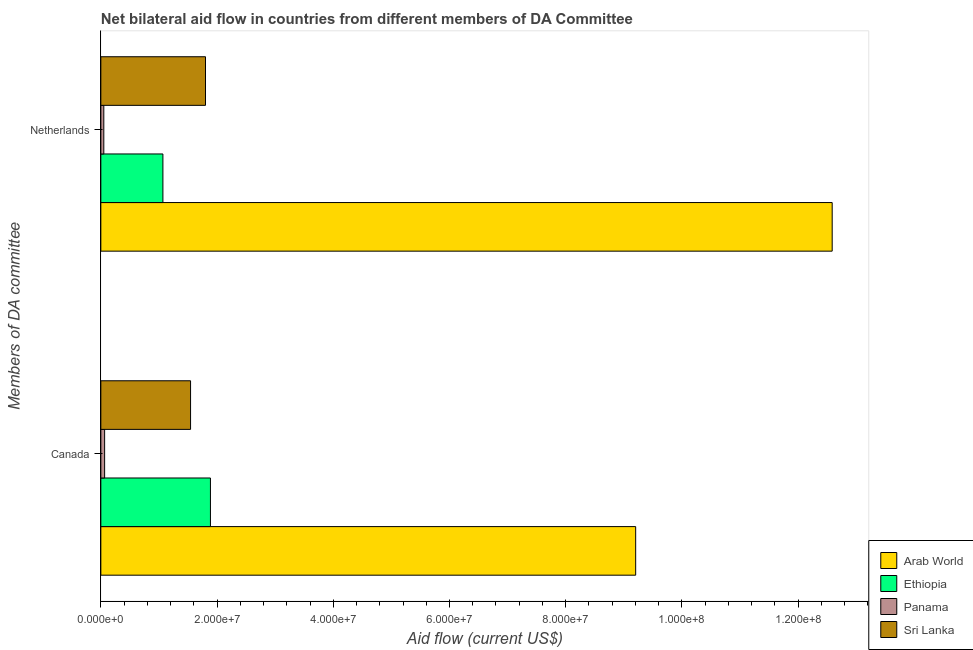How many different coloured bars are there?
Offer a terse response. 4. How many groups of bars are there?
Ensure brevity in your answer.  2. Are the number of bars on each tick of the Y-axis equal?
Your response must be concise. Yes. How many bars are there on the 2nd tick from the top?
Offer a very short reply. 4. How many bars are there on the 1st tick from the bottom?
Offer a terse response. 4. What is the amount of aid given by canada in Arab World?
Your answer should be compact. 9.20e+07. Across all countries, what is the maximum amount of aid given by canada?
Your answer should be very brief. 9.20e+07. Across all countries, what is the minimum amount of aid given by canada?
Offer a terse response. 6.50e+05. In which country was the amount of aid given by canada maximum?
Keep it short and to the point. Arab World. In which country was the amount of aid given by netherlands minimum?
Ensure brevity in your answer.  Panama. What is the total amount of aid given by canada in the graph?
Provide a succinct answer. 1.27e+08. What is the difference between the amount of aid given by canada in Panama and that in Ethiopia?
Make the answer very short. -1.82e+07. What is the difference between the amount of aid given by canada in Ethiopia and the amount of aid given by netherlands in Panama?
Your answer should be compact. 1.84e+07. What is the average amount of aid given by canada per country?
Make the answer very short. 3.17e+07. What is the difference between the amount of aid given by netherlands and amount of aid given by canada in Panama?
Keep it short and to the point. -1.40e+05. What is the ratio of the amount of aid given by netherlands in Panama to that in Arab World?
Your answer should be very brief. 0. Is the amount of aid given by canada in Sri Lanka less than that in Panama?
Offer a terse response. No. What does the 4th bar from the top in Netherlands represents?
Provide a short and direct response. Arab World. What does the 1st bar from the bottom in Canada represents?
Keep it short and to the point. Arab World. Are all the bars in the graph horizontal?
Give a very brief answer. Yes. What is the difference between two consecutive major ticks on the X-axis?
Your response must be concise. 2.00e+07. Are the values on the major ticks of X-axis written in scientific E-notation?
Make the answer very short. Yes. How many legend labels are there?
Ensure brevity in your answer.  4. What is the title of the graph?
Keep it short and to the point. Net bilateral aid flow in countries from different members of DA Committee. Does "Namibia" appear as one of the legend labels in the graph?
Provide a succinct answer. No. What is the label or title of the Y-axis?
Offer a terse response. Members of DA committee. What is the Aid flow (current US$) of Arab World in Canada?
Keep it short and to the point. 9.20e+07. What is the Aid flow (current US$) of Ethiopia in Canada?
Offer a terse response. 1.89e+07. What is the Aid flow (current US$) of Panama in Canada?
Provide a succinct answer. 6.50e+05. What is the Aid flow (current US$) of Sri Lanka in Canada?
Ensure brevity in your answer.  1.54e+07. What is the Aid flow (current US$) of Arab World in Netherlands?
Make the answer very short. 1.26e+08. What is the Aid flow (current US$) in Ethiopia in Netherlands?
Your answer should be compact. 1.07e+07. What is the Aid flow (current US$) of Panama in Netherlands?
Your response must be concise. 5.10e+05. What is the Aid flow (current US$) of Sri Lanka in Netherlands?
Give a very brief answer. 1.80e+07. Across all Members of DA committee, what is the maximum Aid flow (current US$) in Arab World?
Offer a terse response. 1.26e+08. Across all Members of DA committee, what is the maximum Aid flow (current US$) in Ethiopia?
Keep it short and to the point. 1.89e+07. Across all Members of DA committee, what is the maximum Aid flow (current US$) in Panama?
Your response must be concise. 6.50e+05. Across all Members of DA committee, what is the maximum Aid flow (current US$) of Sri Lanka?
Your response must be concise. 1.80e+07. Across all Members of DA committee, what is the minimum Aid flow (current US$) in Arab World?
Your answer should be compact. 9.20e+07. Across all Members of DA committee, what is the minimum Aid flow (current US$) of Ethiopia?
Give a very brief answer. 1.07e+07. Across all Members of DA committee, what is the minimum Aid flow (current US$) in Panama?
Your answer should be very brief. 5.10e+05. Across all Members of DA committee, what is the minimum Aid flow (current US$) in Sri Lanka?
Your answer should be very brief. 1.54e+07. What is the total Aid flow (current US$) in Arab World in the graph?
Your answer should be very brief. 2.18e+08. What is the total Aid flow (current US$) of Ethiopia in the graph?
Provide a short and direct response. 2.95e+07. What is the total Aid flow (current US$) in Panama in the graph?
Your answer should be very brief. 1.16e+06. What is the total Aid flow (current US$) in Sri Lanka in the graph?
Ensure brevity in your answer.  3.34e+07. What is the difference between the Aid flow (current US$) of Arab World in Canada and that in Netherlands?
Provide a succinct answer. -3.38e+07. What is the difference between the Aid flow (current US$) of Ethiopia in Canada and that in Netherlands?
Make the answer very short. 8.18e+06. What is the difference between the Aid flow (current US$) in Sri Lanka in Canada and that in Netherlands?
Keep it short and to the point. -2.57e+06. What is the difference between the Aid flow (current US$) in Arab World in Canada and the Aid flow (current US$) in Ethiopia in Netherlands?
Provide a succinct answer. 8.14e+07. What is the difference between the Aid flow (current US$) of Arab World in Canada and the Aid flow (current US$) of Panama in Netherlands?
Give a very brief answer. 9.15e+07. What is the difference between the Aid flow (current US$) of Arab World in Canada and the Aid flow (current US$) of Sri Lanka in Netherlands?
Your answer should be compact. 7.40e+07. What is the difference between the Aid flow (current US$) in Ethiopia in Canada and the Aid flow (current US$) in Panama in Netherlands?
Ensure brevity in your answer.  1.84e+07. What is the difference between the Aid flow (current US$) in Ethiopia in Canada and the Aid flow (current US$) in Sri Lanka in Netherlands?
Your answer should be compact. 8.50e+05. What is the difference between the Aid flow (current US$) in Panama in Canada and the Aid flow (current US$) in Sri Lanka in Netherlands?
Provide a short and direct response. -1.74e+07. What is the average Aid flow (current US$) in Arab World per Members of DA committee?
Make the answer very short. 1.09e+08. What is the average Aid flow (current US$) in Ethiopia per Members of DA committee?
Make the answer very short. 1.48e+07. What is the average Aid flow (current US$) in Panama per Members of DA committee?
Provide a succinct answer. 5.80e+05. What is the average Aid flow (current US$) of Sri Lanka per Members of DA committee?
Provide a succinct answer. 1.67e+07. What is the difference between the Aid flow (current US$) of Arab World and Aid flow (current US$) of Ethiopia in Canada?
Provide a short and direct response. 7.32e+07. What is the difference between the Aid flow (current US$) of Arab World and Aid flow (current US$) of Panama in Canada?
Ensure brevity in your answer.  9.14e+07. What is the difference between the Aid flow (current US$) of Arab World and Aid flow (current US$) of Sri Lanka in Canada?
Provide a short and direct response. 7.66e+07. What is the difference between the Aid flow (current US$) in Ethiopia and Aid flow (current US$) in Panama in Canada?
Your answer should be compact. 1.82e+07. What is the difference between the Aid flow (current US$) in Ethiopia and Aid flow (current US$) in Sri Lanka in Canada?
Your answer should be compact. 3.42e+06. What is the difference between the Aid flow (current US$) of Panama and Aid flow (current US$) of Sri Lanka in Canada?
Provide a succinct answer. -1.48e+07. What is the difference between the Aid flow (current US$) in Arab World and Aid flow (current US$) in Ethiopia in Netherlands?
Provide a short and direct response. 1.15e+08. What is the difference between the Aid flow (current US$) in Arab World and Aid flow (current US$) in Panama in Netherlands?
Your answer should be compact. 1.25e+08. What is the difference between the Aid flow (current US$) of Arab World and Aid flow (current US$) of Sri Lanka in Netherlands?
Provide a succinct answer. 1.08e+08. What is the difference between the Aid flow (current US$) of Ethiopia and Aid flow (current US$) of Panama in Netherlands?
Your answer should be very brief. 1.02e+07. What is the difference between the Aid flow (current US$) of Ethiopia and Aid flow (current US$) of Sri Lanka in Netherlands?
Your response must be concise. -7.33e+06. What is the difference between the Aid flow (current US$) in Panama and Aid flow (current US$) in Sri Lanka in Netherlands?
Provide a short and direct response. -1.75e+07. What is the ratio of the Aid flow (current US$) of Arab World in Canada to that in Netherlands?
Your answer should be compact. 0.73. What is the ratio of the Aid flow (current US$) in Ethiopia in Canada to that in Netherlands?
Provide a short and direct response. 1.77. What is the ratio of the Aid flow (current US$) in Panama in Canada to that in Netherlands?
Provide a succinct answer. 1.27. What is the ratio of the Aid flow (current US$) in Sri Lanka in Canada to that in Netherlands?
Your response must be concise. 0.86. What is the difference between the highest and the second highest Aid flow (current US$) of Arab World?
Your answer should be compact. 3.38e+07. What is the difference between the highest and the second highest Aid flow (current US$) of Ethiopia?
Ensure brevity in your answer.  8.18e+06. What is the difference between the highest and the second highest Aid flow (current US$) of Sri Lanka?
Provide a short and direct response. 2.57e+06. What is the difference between the highest and the lowest Aid flow (current US$) of Arab World?
Give a very brief answer. 3.38e+07. What is the difference between the highest and the lowest Aid flow (current US$) in Ethiopia?
Your answer should be very brief. 8.18e+06. What is the difference between the highest and the lowest Aid flow (current US$) of Sri Lanka?
Provide a short and direct response. 2.57e+06. 